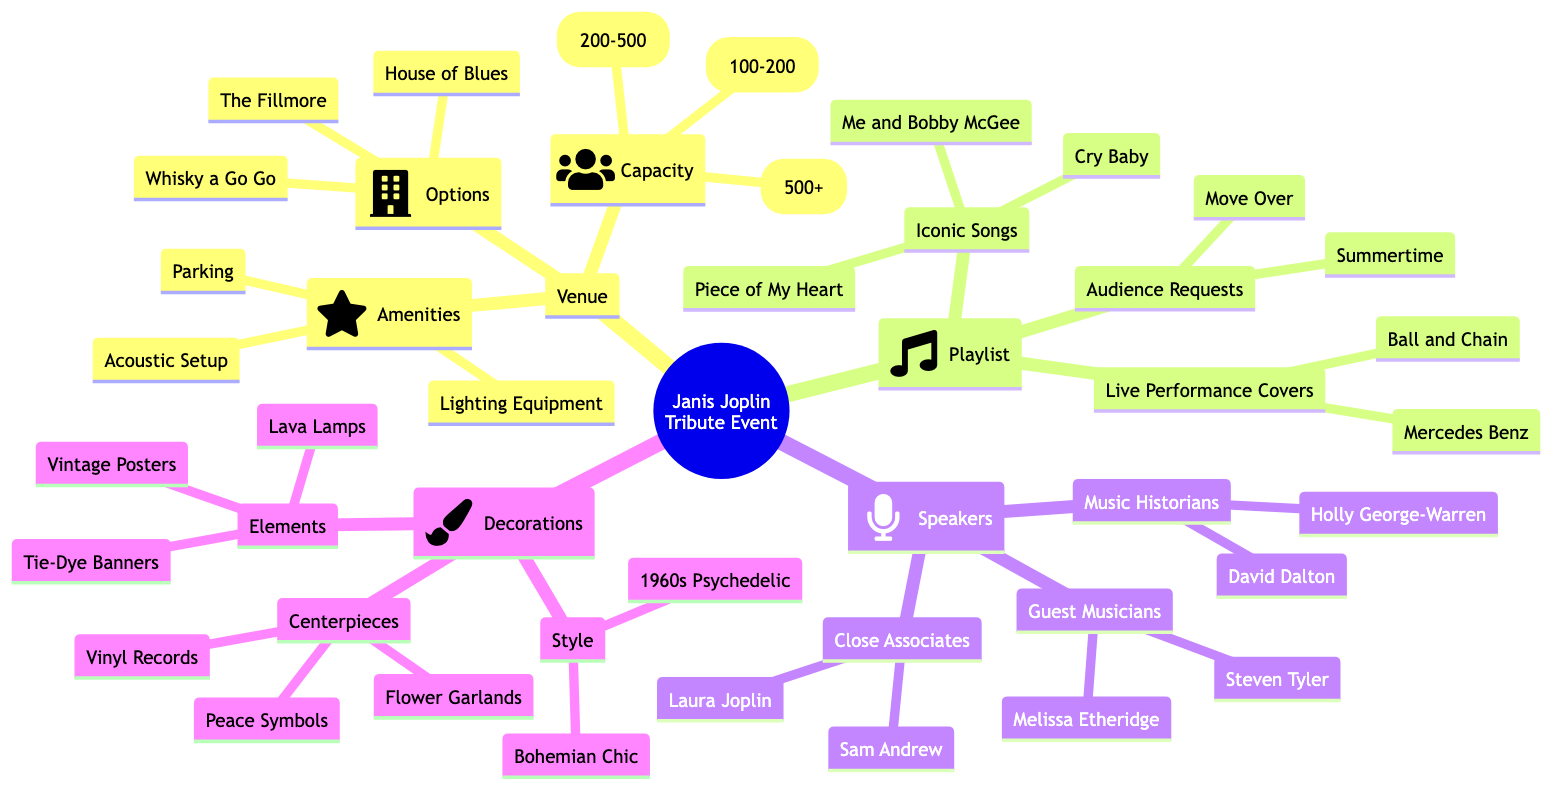What's one of the options for the venue? The venue node contains a list of options for locations to host the tribute event. These options include "The Fillmore," "Whisky a Go Go," and "House of Blues."
Answer: The Fillmore How many iconic songs are listed in the playlist? The playlist section under "Iconic Songs" includes three titles: "Piece of My Heart," "Me and Bobby McGee," and "Cry Baby." Thus, there are three iconic songs listed.
Answer: 3 What capacities are available for the venue? The capacity node lists three options: "Small (100-200)," "Medium (200-500)," and "Large (500+)," showing all the available capacity choices for the tribute event's venue.
Answer: Small, Medium, Large Which type of decorations includes vintage posters? Within the decorations section, the node for "Elements" specifically mentions items that include "Vintage Posters." This shows that vintage posters are categorized under the decoration elements.
Answer: Elements Who are some guest musicians planned to speak at the event? The speakers section under the "Guest Musicians" node includes two names: "Melissa Etheridge" and "Steven Tyler." This indicates that they are among the guest musicians who will be speaking at the event.
Answer: Melissa Etheridge, Steven Tyler Which decor style is related to the 1960s? The "Style" node under decorations lists "1960s Psychedelic" and "Bohemian Chic," with the first option explicitly denoting the 1960s theme related to the event's decor.
Answer: 1960s Psychedelic Name an iconic song from the playlist. The "Iconic Songs" node in the playlist lists "Piece of My Heart," "Me and Bobby McGee," and "Cry Baby," from which any can be named as an example of an iconic song from the playlist.
Answer: Piece of My Heart How many categories of speakers are listed? The speakers section categorizes speakers into three groups: "Guest Musicians," "Music Historians," and "Close Associates." This indicates that there are three distinct categories under speakers.
Answer: 3 What centerpiece is related to music? The "Centerpieces" node in the decorations section includes "Vinyl Records," which relates directly to music, signifying that it is one of the chosen centerpieces for the event.
Answer: Vinyl Records 